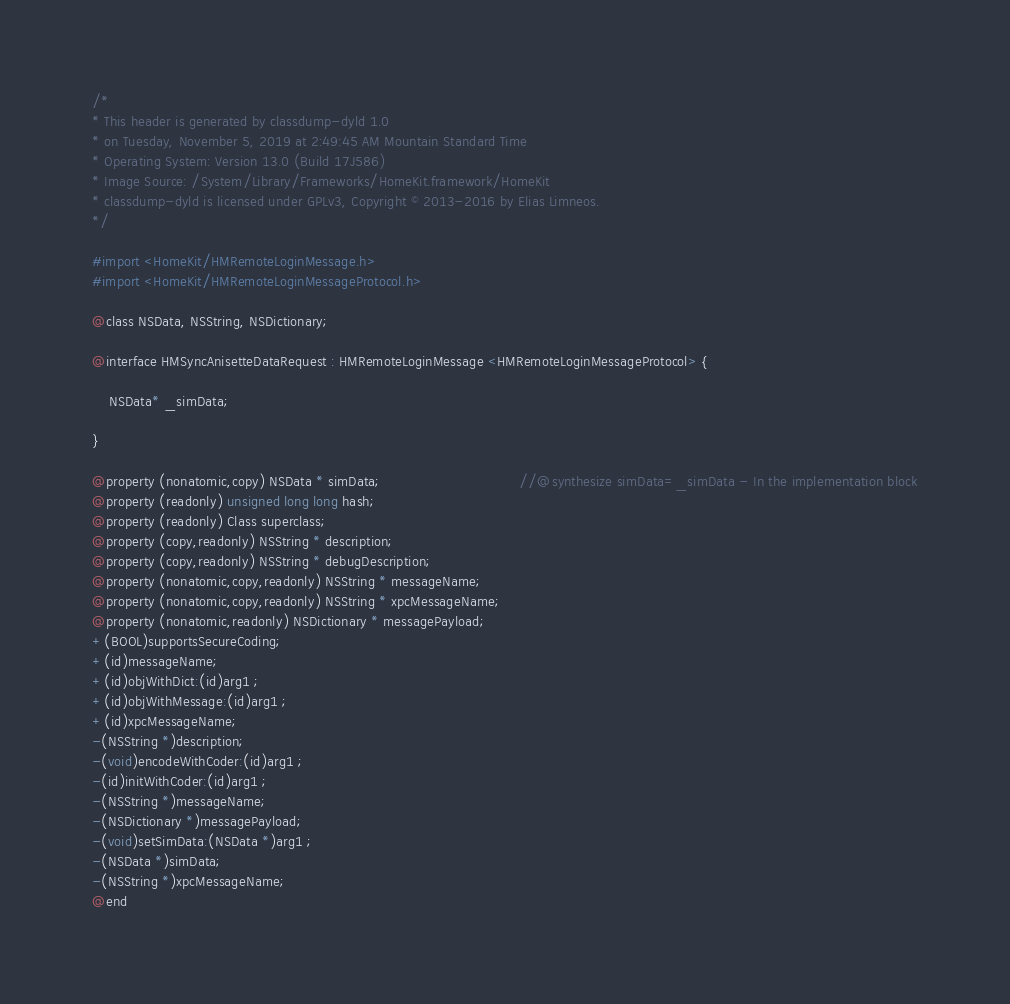Convert code to text. <code><loc_0><loc_0><loc_500><loc_500><_C_>/*
* This header is generated by classdump-dyld 1.0
* on Tuesday, November 5, 2019 at 2:49:45 AM Mountain Standard Time
* Operating System: Version 13.0 (Build 17J586)
* Image Source: /System/Library/Frameworks/HomeKit.framework/HomeKit
* classdump-dyld is licensed under GPLv3, Copyright © 2013-2016 by Elias Limneos.
*/

#import <HomeKit/HMRemoteLoginMessage.h>
#import <HomeKit/HMRemoteLoginMessageProtocol.h>

@class NSData, NSString, NSDictionary;

@interface HMSyncAnisetteDataRequest : HMRemoteLoginMessage <HMRemoteLoginMessageProtocol> {

	NSData* _simData;

}

@property (nonatomic,copy) NSData * simData;                                //@synthesize simData=_simData - In the implementation block
@property (readonly) unsigned long long hash; 
@property (readonly) Class superclass; 
@property (copy,readonly) NSString * description; 
@property (copy,readonly) NSString * debugDescription; 
@property (nonatomic,copy,readonly) NSString * messageName; 
@property (nonatomic,copy,readonly) NSString * xpcMessageName; 
@property (nonatomic,readonly) NSDictionary * messagePayload; 
+(BOOL)supportsSecureCoding;
+(id)messageName;
+(id)objWithDict:(id)arg1 ;
+(id)objWithMessage:(id)arg1 ;
+(id)xpcMessageName;
-(NSString *)description;
-(void)encodeWithCoder:(id)arg1 ;
-(id)initWithCoder:(id)arg1 ;
-(NSString *)messageName;
-(NSDictionary *)messagePayload;
-(void)setSimData:(NSData *)arg1 ;
-(NSData *)simData;
-(NSString *)xpcMessageName;
@end

</code> 